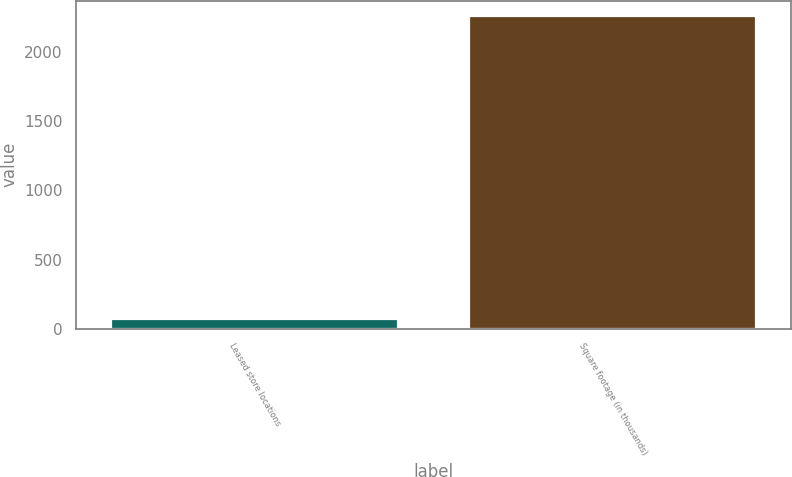<chart> <loc_0><loc_0><loc_500><loc_500><bar_chart><fcel>Leased store locations<fcel>Square footage (in thousands)<nl><fcel>68<fcel>2257<nl></chart> 